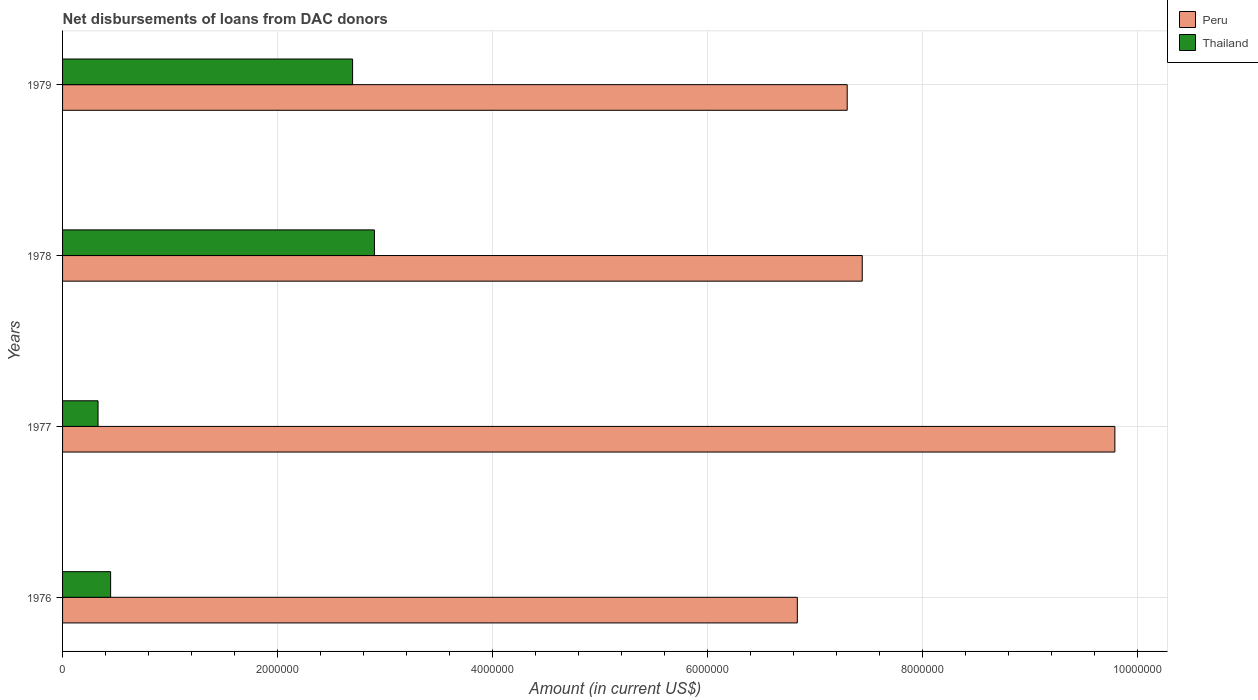How many groups of bars are there?
Your response must be concise. 4. Are the number of bars on each tick of the Y-axis equal?
Give a very brief answer. Yes. What is the label of the 2nd group of bars from the top?
Your answer should be very brief. 1978. In how many cases, is the number of bars for a given year not equal to the number of legend labels?
Offer a terse response. 0. What is the amount of loans disbursed in Peru in 1976?
Ensure brevity in your answer.  6.84e+06. Across all years, what is the maximum amount of loans disbursed in Peru?
Offer a terse response. 9.79e+06. Across all years, what is the minimum amount of loans disbursed in Peru?
Make the answer very short. 6.84e+06. In which year was the amount of loans disbursed in Thailand minimum?
Keep it short and to the point. 1977. What is the total amount of loans disbursed in Thailand in the graph?
Offer a terse response. 6.38e+06. What is the difference between the amount of loans disbursed in Peru in 1978 and that in 1979?
Your answer should be compact. 1.40e+05. What is the difference between the amount of loans disbursed in Thailand in 1977 and the amount of loans disbursed in Peru in 1976?
Your answer should be very brief. -6.50e+06. What is the average amount of loans disbursed in Peru per year?
Make the answer very short. 7.84e+06. In the year 1978, what is the difference between the amount of loans disbursed in Peru and amount of loans disbursed in Thailand?
Give a very brief answer. 4.54e+06. What is the ratio of the amount of loans disbursed in Thailand in 1976 to that in 1977?
Make the answer very short. 1.35. Is the amount of loans disbursed in Thailand in 1976 less than that in 1979?
Ensure brevity in your answer.  Yes. Is the difference between the amount of loans disbursed in Peru in 1977 and 1978 greater than the difference between the amount of loans disbursed in Thailand in 1977 and 1978?
Your answer should be very brief. Yes. What is the difference between the highest and the second highest amount of loans disbursed in Peru?
Keep it short and to the point. 2.35e+06. What is the difference between the highest and the lowest amount of loans disbursed in Thailand?
Your answer should be very brief. 2.57e+06. In how many years, is the amount of loans disbursed in Thailand greater than the average amount of loans disbursed in Thailand taken over all years?
Give a very brief answer. 2. Is the sum of the amount of loans disbursed in Thailand in 1976 and 1977 greater than the maximum amount of loans disbursed in Peru across all years?
Provide a short and direct response. No. What does the 1st bar from the top in 1977 represents?
Give a very brief answer. Thailand. What does the 1st bar from the bottom in 1979 represents?
Offer a terse response. Peru. How many bars are there?
Provide a succinct answer. 8. How many years are there in the graph?
Ensure brevity in your answer.  4. What is the difference between two consecutive major ticks on the X-axis?
Offer a very short reply. 2.00e+06. Are the values on the major ticks of X-axis written in scientific E-notation?
Your response must be concise. No. Where does the legend appear in the graph?
Provide a short and direct response. Top right. How many legend labels are there?
Offer a terse response. 2. What is the title of the graph?
Keep it short and to the point. Net disbursements of loans from DAC donors. What is the label or title of the X-axis?
Offer a very short reply. Amount (in current US$). What is the label or title of the Y-axis?
Ensure brevity in your answer.  Years. What is the Amount (in current US$) in Peru in 1976?
Offer a terse response. 6.84e+06. What is the Amount (in current US$) in Thailand in 1976?
Your answer should be very brief. 4.47e+05. What is the Amount (in current US$) of Peru in 1977?
Ensure brevity in your answer.  9.79e+06. What is the Amount (in current US$) in Thailand in 1977?
Offer a terse response. 3.30e+05. What is the Amount (in current US$) of Peru in 1978?
Make the answer very short. 7.44e+06. What is the Amount (in current US$) of Thailand in 1978?
Offer a very short reply. 2.90e+06. What is the Amount (in current US$) of Peru in 1979?
Your response must be concise. 7.30e+06. What is the Amount (in current US$) of Thailand in 1979?
Ensure brevity in your answer.  2.70e+06. Across all years, what is the maximum Amount (in current US$) of Peru?
Make the answer very short. 9.79e+06. Across all years, what is the maximum Amount (in current US$) in Thailand?
Make the answer very short. 2.90e+06. Across all years, what is the minimum Amount (in current US$) of Peru?
Your response must be concise. 6.84e+06. What is the total Amount (in current US$) of Peru in the graph?
Your answer should be very brief. 3.14e+07. What is the total Amount (in current US$) in Thailand in the graph?
Make the answer very short. 6.38e+06. What is the difference between the Amount (in current US$) in Peru in 1976 and that in 1977?
Give a very brief answer. -2.95e+06. What is the difference between the Amount (in current US$) of Thailand in 1976 and that in 1977?
Your answer should be very brief. 1.17e+05. What is the difference between the Amount (in current US$) in Peru in 1976 and that in 1978?
Provide a short and direct response. -6.04e+05. What is the difference between the Amount (in current US$) in Thailand in 1976 and that in 1978?
Give a very brief answer. -2.45e+06. What is the difference between the Amount (in current US$) in Peru in 1976 and that in 1979?
Make the answer very short. -4.64e+05. What is the difference between the Amount (in current US$) of Thailand in 1976 and that in 1979?
Provide a succinct answer. -2.25e+06. What is the difference between the Amount (in current US$) of Peru in 1977 and that in 1978?
Ensure brevity in your answer.  2.35e+06. What is the difference between the Amount (in current US$) of Thailand in 1977 and that in 1978?
Your answer should be compact. -2.57e+06. What is the difference between the Amount (in current US$) of Peru in 1977 and that in 1979?
Your answer should be very brief. 2.49e+06. What is the difference between the Amount (in current US$) of Thailand in 1977 and that in 1979?
Offer a very short reply. -2.37e+06. What is the difference between the Amount (in current US$) in Peru in 1978 and that in 1979?
Make the answer very short. 1.40e+05. What is the difference between the Amount (in current US$) of Thailand in 1978 and that in 1979?
Offer a very short reply. 2.03e+05. What is the difference between the Amount (in current US$) of Peru in 1976 and the Amount (in current US$) of Thailand in 1977?
Your answer should be very brief. 6.50e+06. What is the difference between the Amount (in current US$) of Peru in 1976 and the Amount (in current US$) of Thailand in 1978?
Keep it short and to the point. 3.93e+06. What is the difference between the Amount (in current US$) in Peru in 1976 and the Amount (in current US$) in Thailand in 1979?
Ensure brevity in your answer.  4.14e+06. What is the difference between the Amount (in current US$) in Peru in 1977 and the Amount (in current US$) in Thailand in 1978?
Offer a very short reply. 6.89e+06. What is the difference between the Amount (in current US$) of Peru in 1977 and the Amount (in current US$) of Thailand in 1979?
Keep it short and to the point. 7.09e+06. What is the difference between the Amount (in current US$) of Peru in 1978 and the Amount (in current US$) of Thailand in 1979?
Provide a short and direct response. 4.74e+06. What is the average Amount (in current US$) of Peru per year?
Give a very brief answer. 7.84e+06. What is the average Amount (in current US$) of Thailand per year?
Make the answer very short. 1.59e+06. In the year 1976, what is the difference between the Amount (in current US$) of Peru and Amount (in current US$) of Thailand?
Your answer should be very brief. 6.39e+06. In the year 1977, what is the difference between the Amount (in current US$) in Peru and Amount (in current US$) in Thailand?
Offer a very short reply. 9.46e+06. In the year 1978, what is the difference between the Amount (in current US$) of Peru and Amount (in current US$) of Thailand?
Your response must be concise. 4.54e+06. In the year 1979, what is the difference between the Amount (in current US$) in Peru and Amount (in current US$) in Thailand?
Your answer should be compact. 4.60e+06. What is the ratio of the Amount (in current US$) in Peru in 1976 to that in 1977?
Your response must be concise. 0.7. What is the ratio of the Amount (in current US$) of Thailand in 1976 to that in 1977?
Give a very brief answer. 1.35. What is the ratio of the Amount (in current US$) of Peru in 1976 to that in 1978?
Keep it short and to the point. 0.92. What is the ratio of the Amount (in current US$) of Thailand in 1976 to that in 1978?
Provide a succinct answer. 0.15. What is the ratio of the Amount (in current US$) of Peru in 1976 to that in 1979?
Offer a terse response. 0.94. What is the ratio of the Amount (in current US$) of Thailand in 1976 to that in 1979?
Offer a very short reply. 0.17. What is the ratio of the Amount (in current US$) of Peru in 1977 to that in 1978?
Your answer should be compact. 1.32. What is the ratio of the Amount (in current US$) in Thailand in 1977 to that in 1978?
Keep it short and to the point. 0.11. What is the ratio of the Amount (in current US$) in Peru in 1977 to that in 1979?
Your answer should be compact. 1.34. What is the ratio of the Amount (in current US$) of Thailand in 1977 to that in 1979?
Your answer should be very brief. 0.12. What is the ratio of the Amount (in current US$) in Peru in 1978 to that in 1979?
Your response must be concise. 1.02. What is the ratio of the Amount (in current US$) of Thailand in 1978 to that in 1979?
Your response must be concise. 1.08. What is the difference between the highest and the second highest Amount (in current US$) in Peru?
Your answer should be very brief. 2.35e+06. What is the difference between the highest and the second highest Amount (in current US$) in Thailand?
Offer a very short reply. 2.03e+05. What is the difference between the highest and the lowest Amount (in current US$) in Peru?
Give a very brief answer. 2.95e+06. What is the difference between the highest and the lowest Amount (in current US$) in Thailand?
Offer a very short reply. 2.57e+06. 